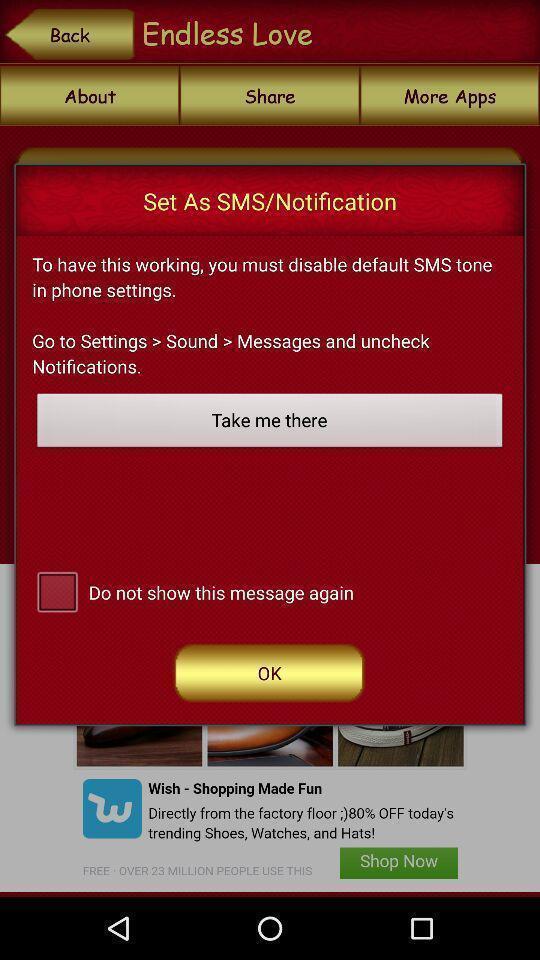Give me a narrative description of this picture. Pop-up showing instructions to uncheck notifications. 